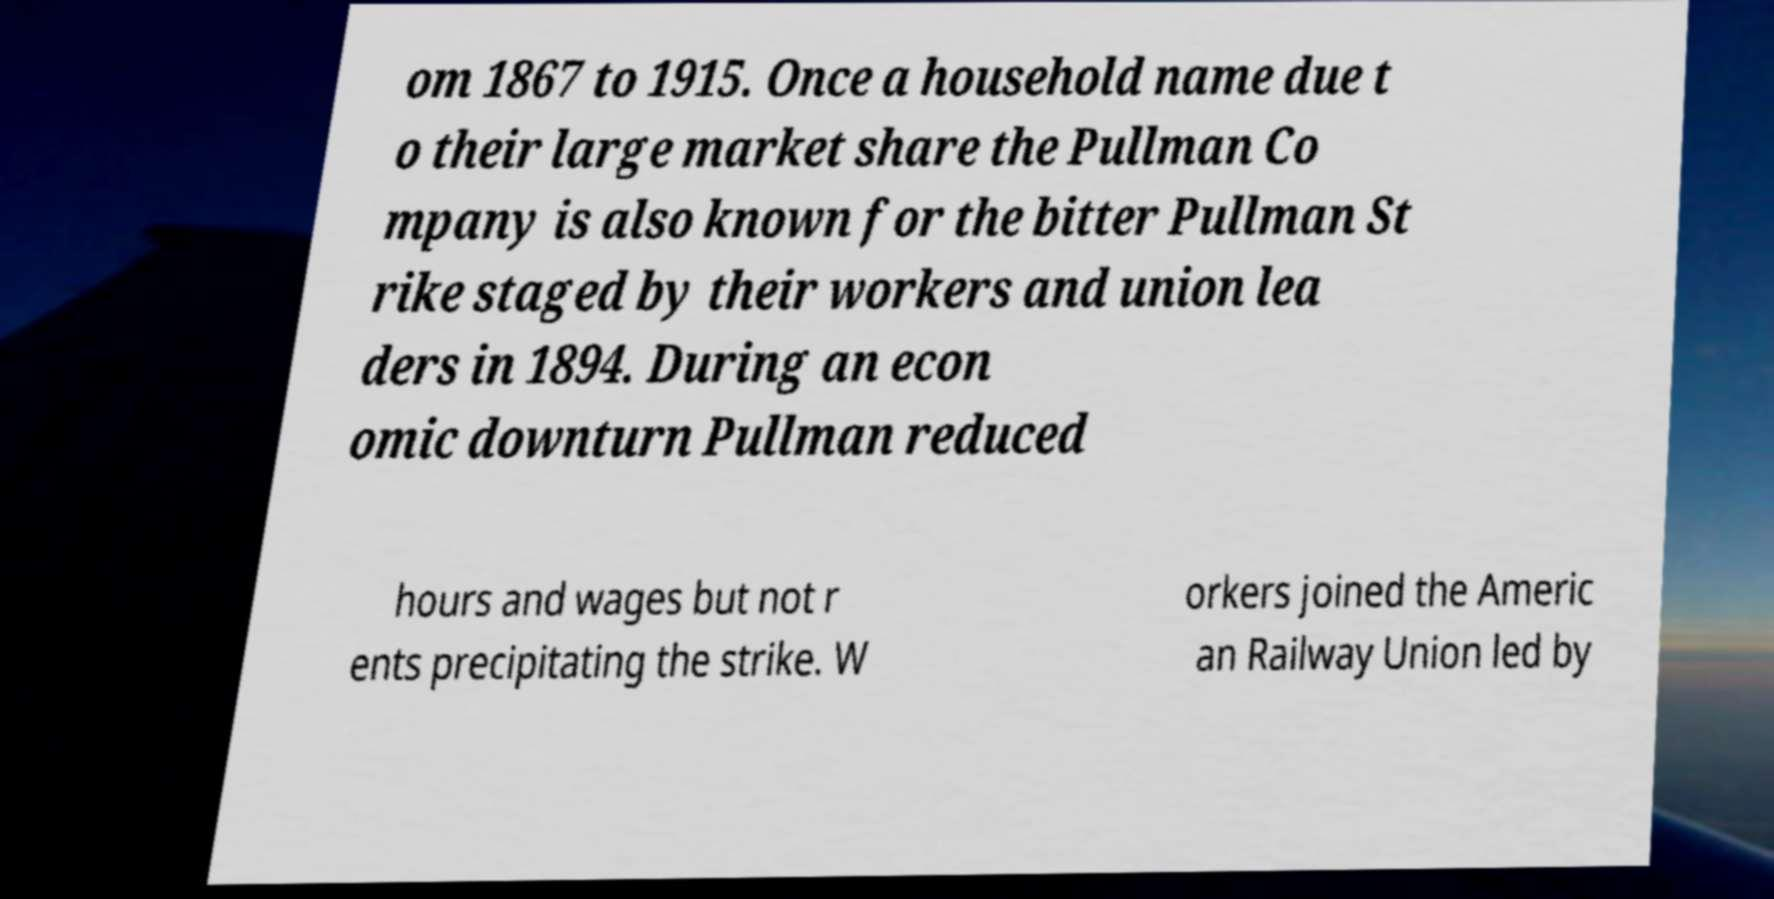There's text embedded in this image that I need extracted. Can you transcribe it verbatim? om 1867 to 1915. Once a household name due t o their large market share the Pullman Co mpany is also known for the bitter Pullman St rike staged by their workers and union lea ders in 1894. During an econ omic downturn Pullman reduced hours and wages but not r ents precipitating the strike. W orkers joined the Americ an Railway Union led by 